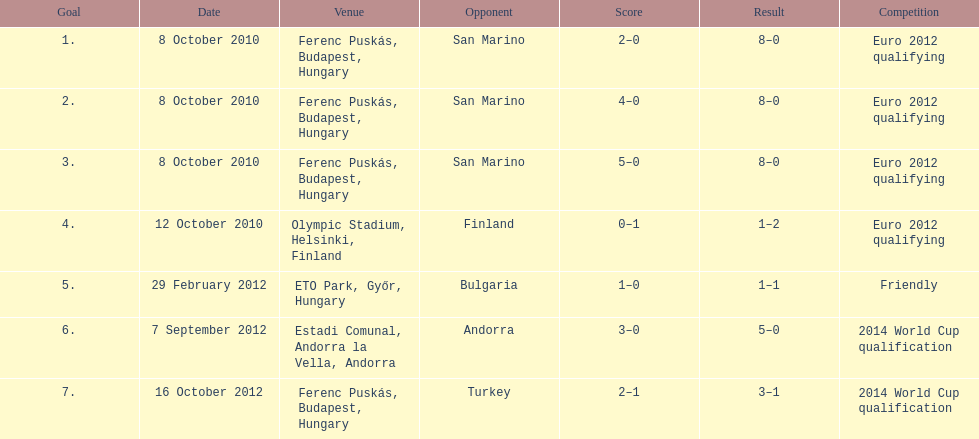How many games did he score but his team lost? 1. 